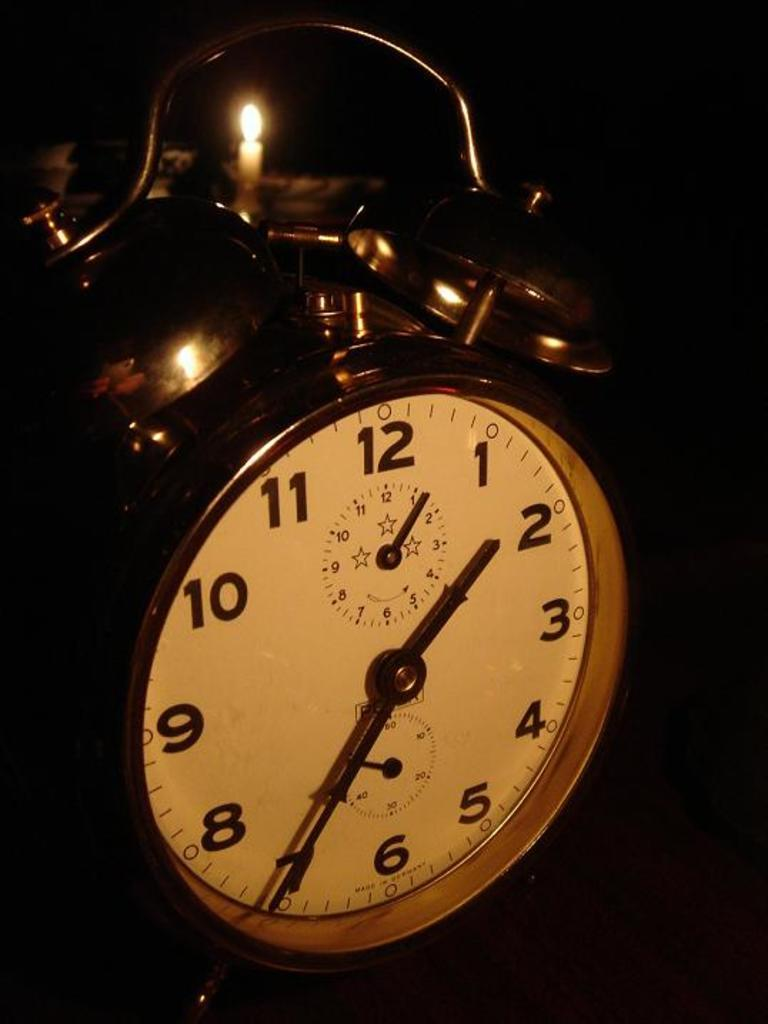Provide a one-sentence caption for the provided image. A clock with 1 to 12 written on it. 